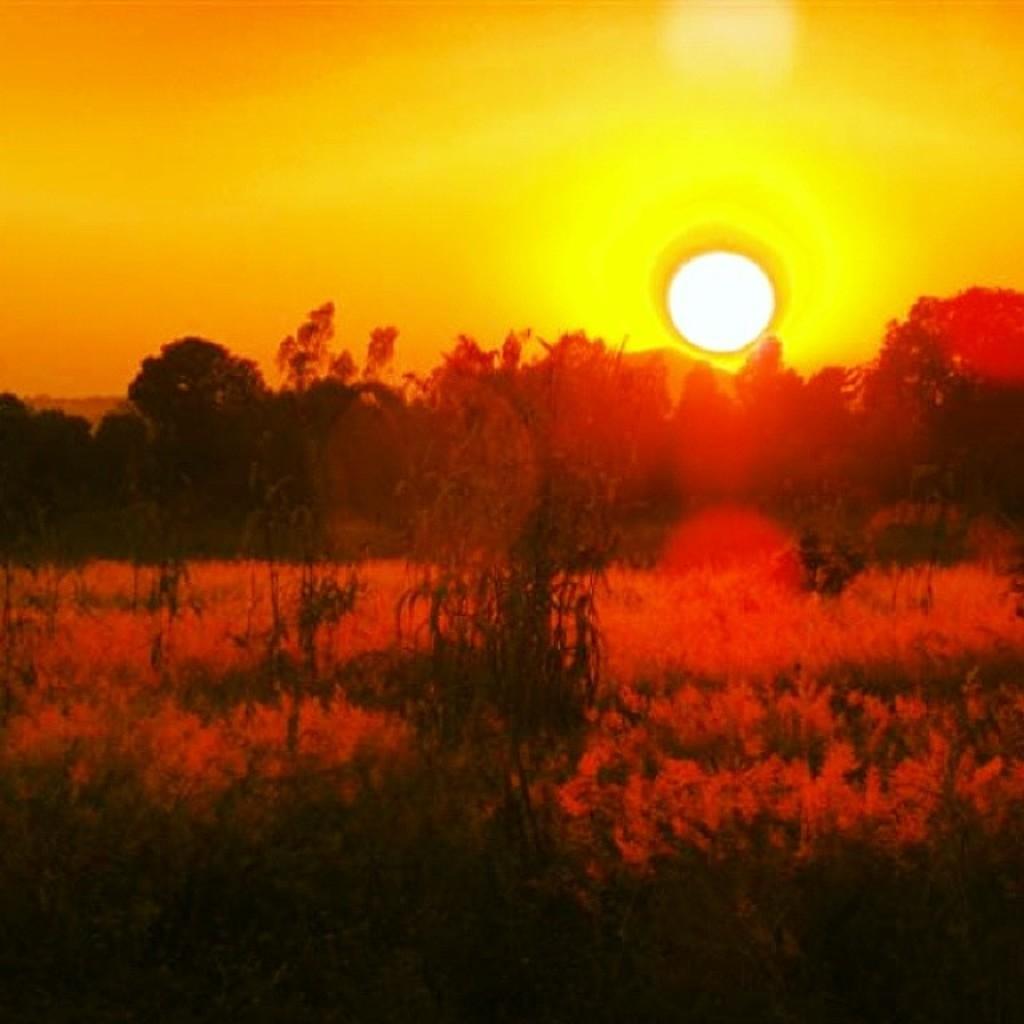In one or two sentences, can you explain what this image depicts? In this picture I can see trees and I can see sun in the sky and looks like few plants on the ground. 